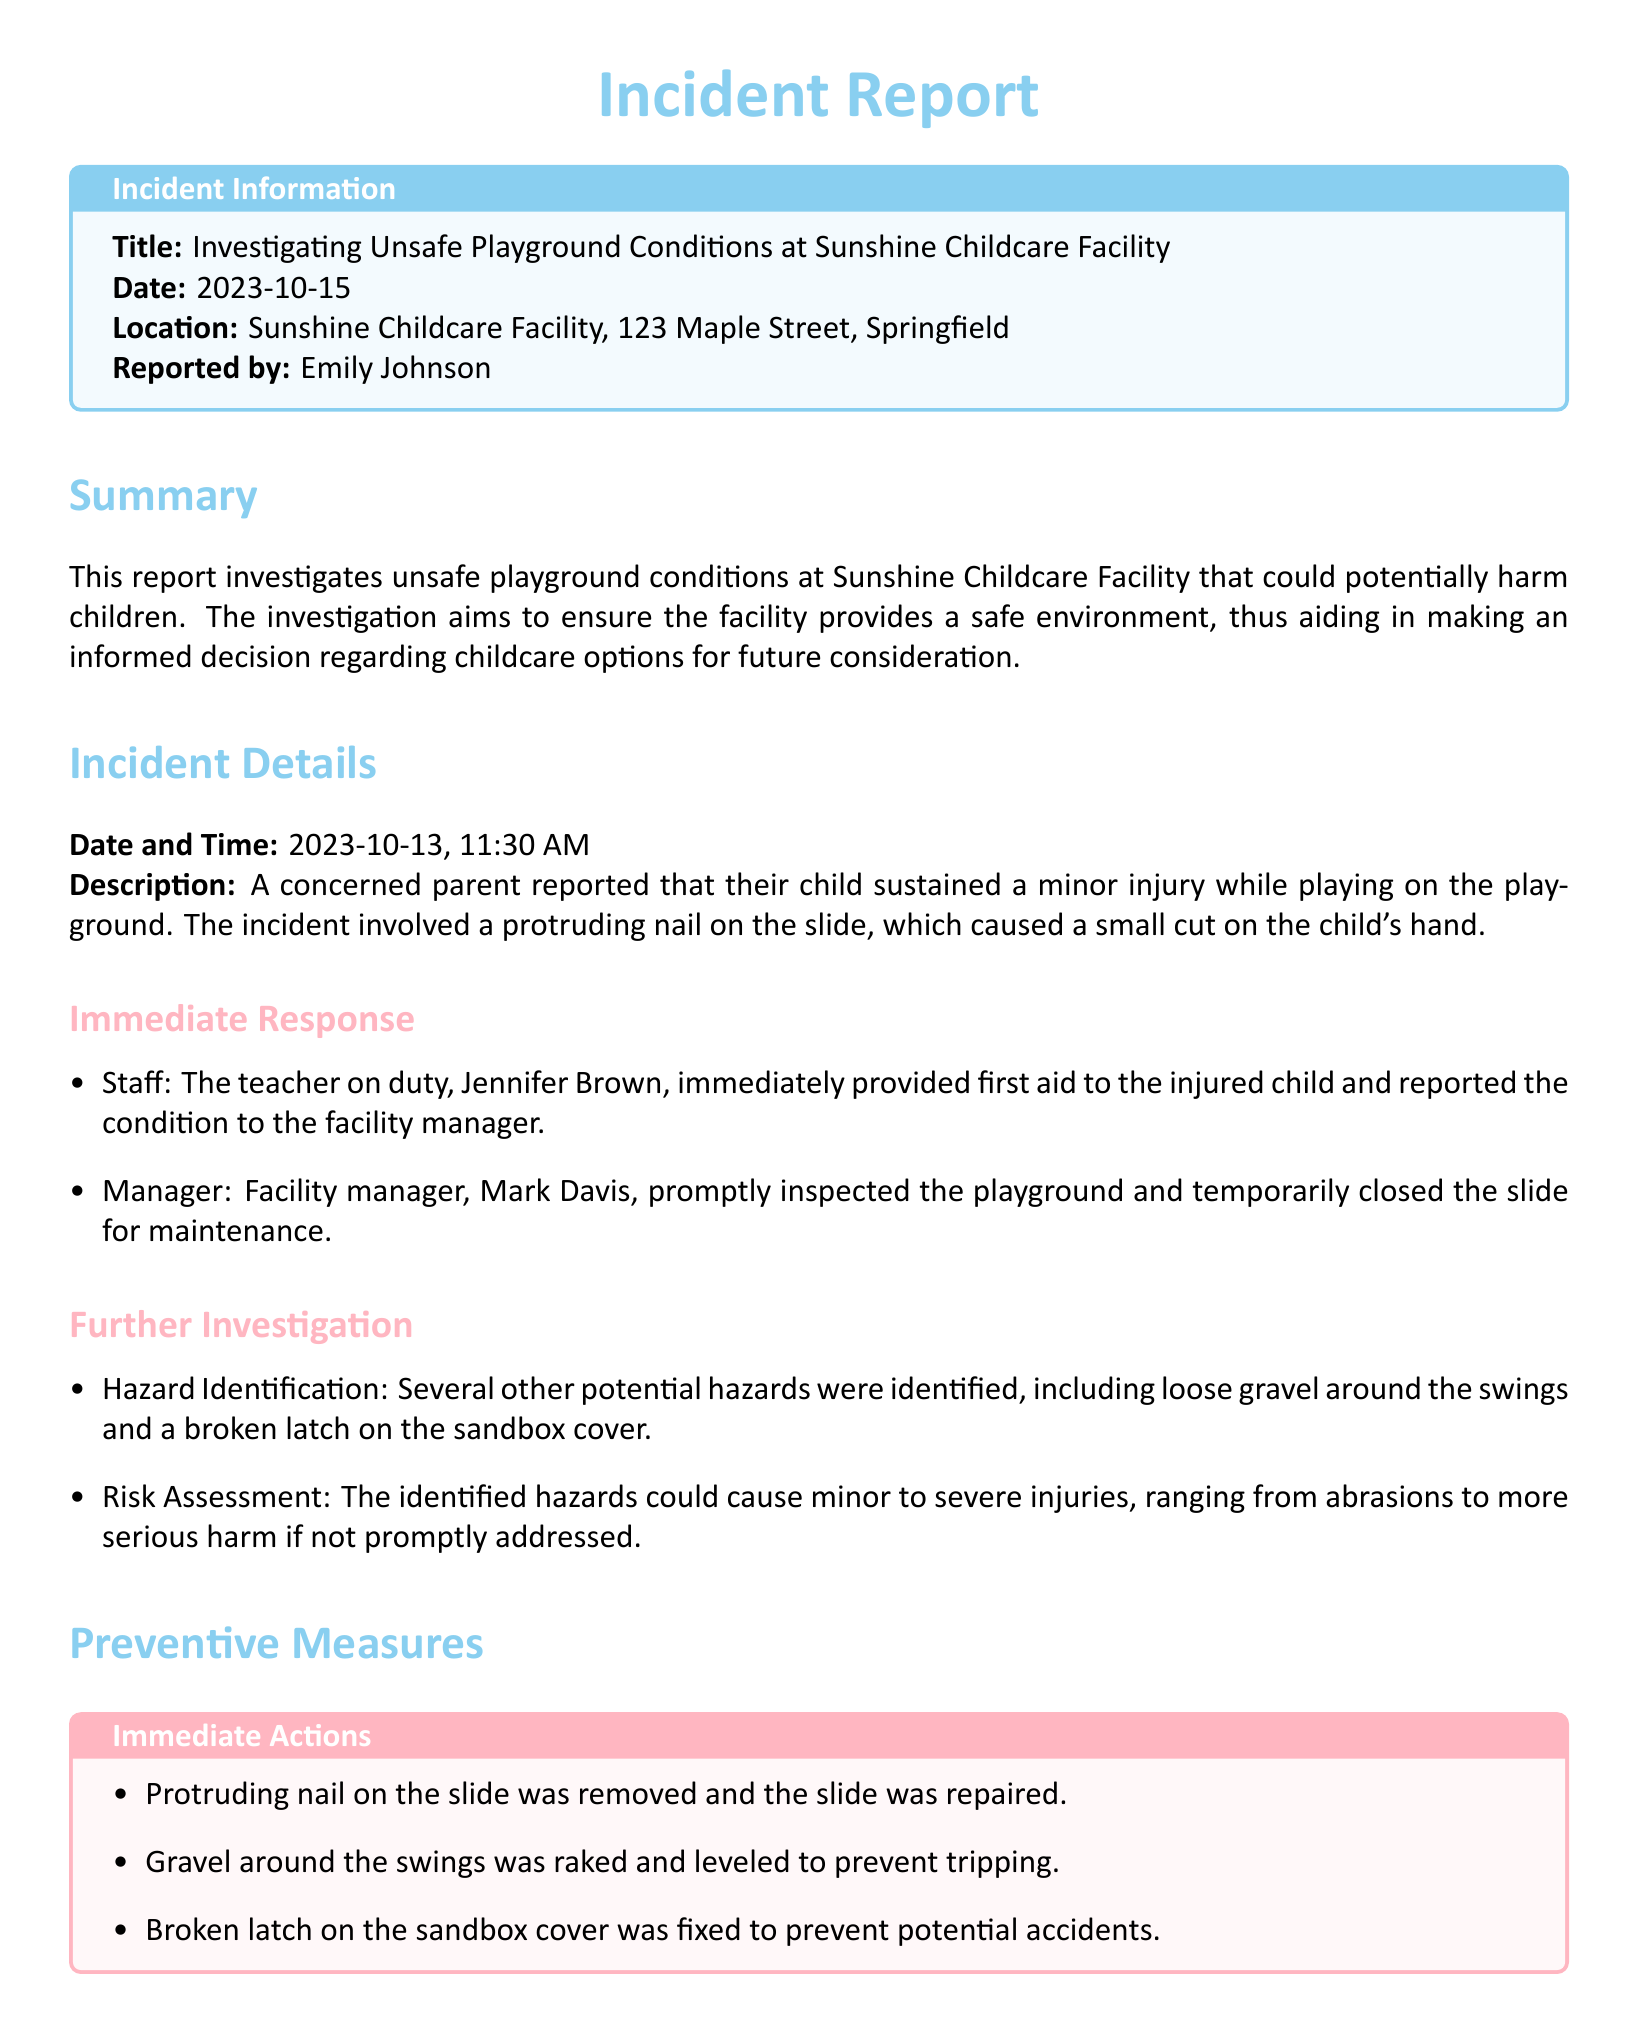what is the title of the report? The title of the report is found in the incident information section.
Answer: Investigating Unsafe Playground Conditions at Sunshine Childcare Facility who reported the incident? The report specifies the person who filed the incident report.
Answer: Emily Johnson when did the incident occur? The date of the incident is mentioned in the incident details section.
Answer: 2023-10-13 what immediate action was taken by the teacher? The document describes the response of the teacher on duty to the incident.
Answer: Provided first aid what potential hazards were identified? The report lists the identified hazards during the further investigation.
Answer: Loose gravel around the swings and a broken latch on the sandbox cover how often will safety inspections be conducted? The long-term actions mentioned in the report indicate how regular the safety inspections will be.
Answer: Monthly what was the cause of the child's minor injury? The incident report explains the reason for the child's injury during the incident.
Answer: Protruding nail on the slide who inspected the playground after the incident? The report notes the individual who inspected the playground following the incident report.
Answer: Mark Davis what is a long-term action to improve safety? The document outlines one of the long-term actions proposed to enhance safety in the facility.
Answer: Monthly safety inspections scheduled 